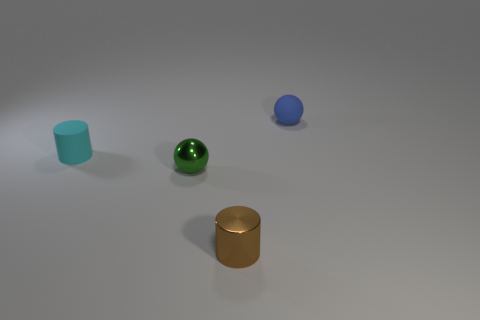Is there anything else that is the same color as the rubber cylinder?
Your answer should be very brief. No. There is a metal object in front of the green ball; what is its shape?
Your response must be concise. Cylinder. Is the number of cyan things greater than the number of small things?
Your answer should be very brief. No. How many things are small spheres that are on the left side of the tiny blue rubber object or small objects that are in front of the blue thing?
Give a very brief answer. 3. How many small cylinders are right of the tiny green sphere and behind the brown metallic cylinder?
Offer a very short reply. 0. Is the brown thing made of the same material as the green thing?
Provide a succinct answer. Yes. The small blue thing that is behind the ball that is in front of the tiny rubber object to the left of the small matte sphere is what shape?
Your response must be concise. Sphere. There is a object that is behind the green shiny ball and left of the tiny blue object; what is it made of?
Keep it short and to the point. Rubber. What color is the object in front of the small sphere in front of the small blue rubber ball behind the green object?
Make the answer very short. Brown. What number of cyan things are small metal cylinders or tiny matte cylinders?
Ensure brevity in your answer.  1. 